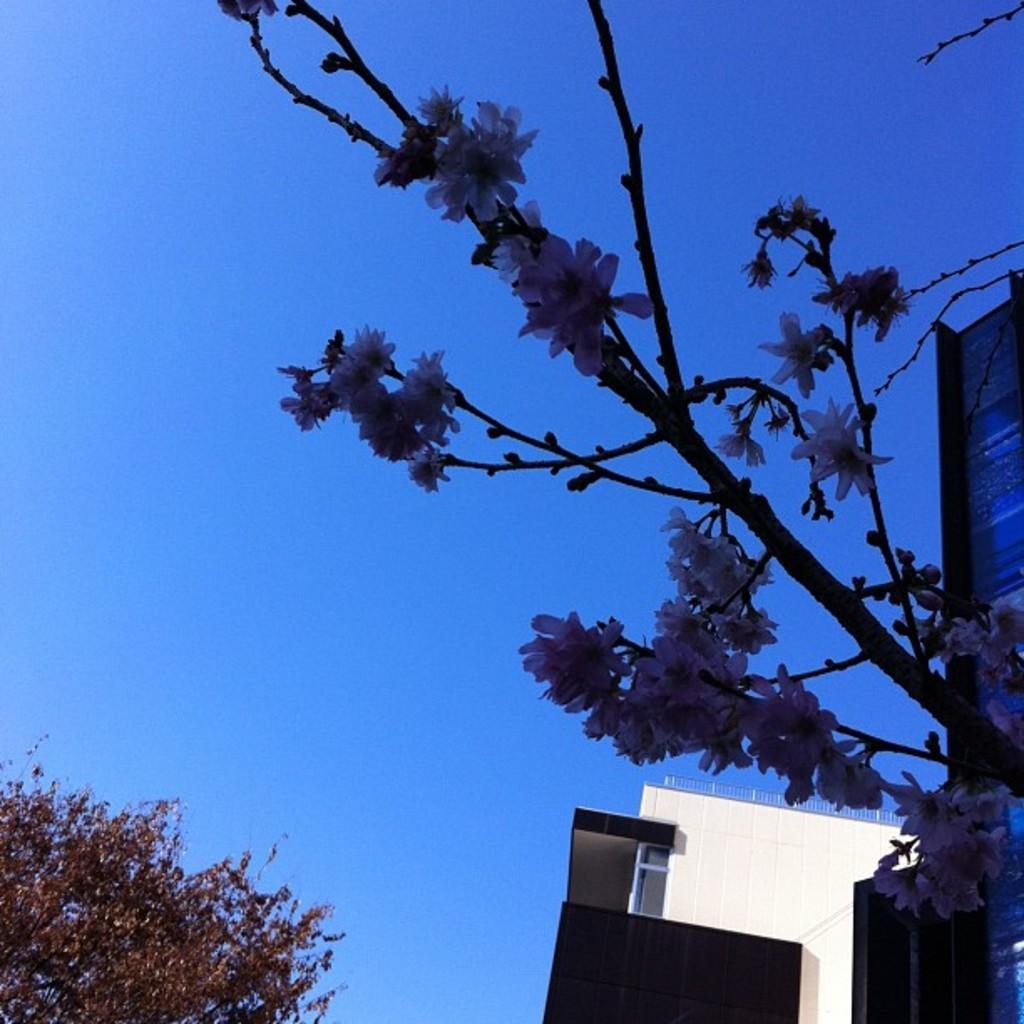Could you give a brief overview of what you see in this image? In this image, we can see a flower plants. Background we can see walls, railings, glass object, tree and sky. 